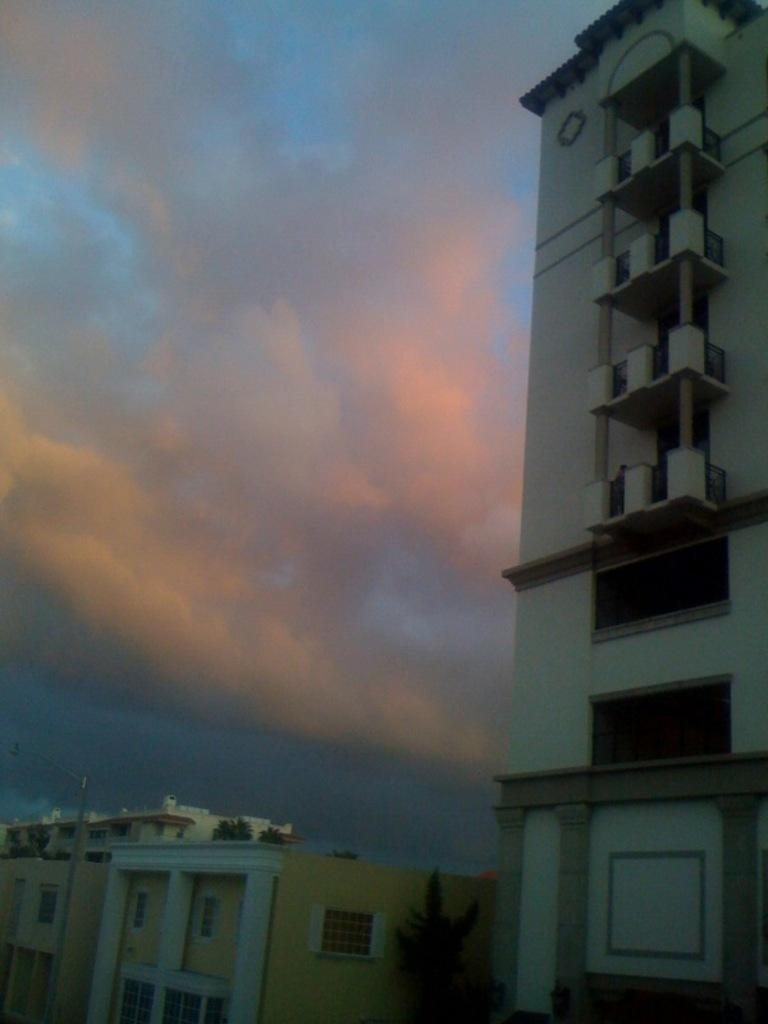What type of structures are present in the image? There is a group of buildings in the image. What else can be seen in the image besides the buildings? There is a pole and a tree in the image. What is the condition of the sky in the image? The sky is visible in the background of the image, and it is cloudy. Can you tell me how many boys are playing with a quince in the image? There are no boys or quince present in the image. 